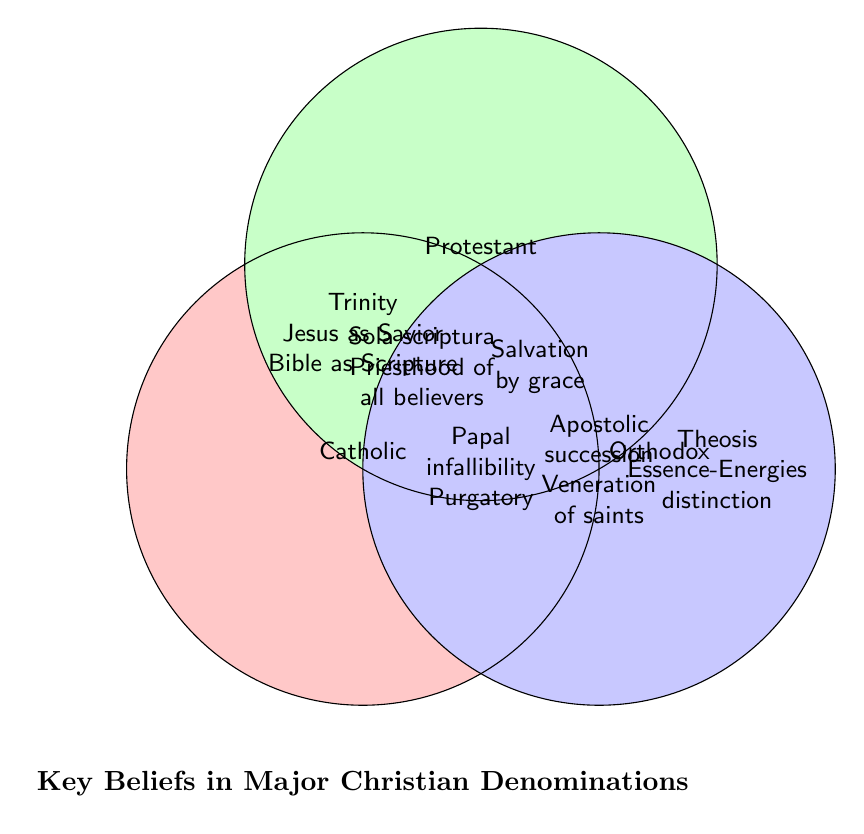What three beliefs are shared by all three denominations? The center of the Venn Diagram lists beliefs shared by all three denominations. These are "Trinity," "Jesus as Savior," and "Bible as Scripture."
Answer: Trinity, Jesus as Savior, Bible as Scripture Which belief is unique to Catholics? The section of the Venn Diagram that only overlaps with the Catholic circle lists beliefs unique to this denomination. These beliefs are "Papal infallibility" and "Purgatory."
Answer: Papal infallibility, Purgatory Which denominations believe in "Salvation by grace"? The section that overlaps between Catholic and Protestant denominations shows the belief "Salvation by grace."
Answer: Catholic, Protestant What's common between Catholic and Orthodox churches but not Protestant? The overlapping section between Catholic and Orthodox denominations, excluding the Protestant circle, lists "Apostolic succession" and "Veneration of saints."
Answer: Apostolic succession, Veneration of saints How many unique beliefs does the Orthodox denomination have on the diagram? The area exclusive to the Orthodox circle lists its unique beliefs. These beliefs are "Theosis" and "Essence-Energies distinction." Thus, there are two unique beliefs.
Answer: 2 beliefs Which belief is unique to the Protestant denomination? The section of the Venn Diagram that only overlaps with the Protestant circle lists beliefs unique to this denomination. These beliefs are "Sola scriptura" and "Priesthood of all believers."
Answer: Sola scriptura, Priesthood of all believers Are there more beliefs exclusive to Catholics or Protestants? The Catholic denomination has two exclusive beliefs ("Papal infallibility" and "Purgatory") and the Protestant denomination has two exclusive beliefs ("Sola scriptura" and "Priesthood of all believers"). Both have the same number of exclusive beliefs.
Answer: Same amount Which common belief do Catholic and Orthodox denominations share that Protestant does not? The overlapping section between Catholic and Orthodox denominations, excluding the Protestant circle, lists their common beliefs. These are "Apostolic succession" and "Veneration of saints."
Answer: Apostolic succession, Veneration of saints What belief differentiates the Orthodox denomination from the others? The exclusive beliefs listed in the Orthodox circle differentiate it from the others. These are "Theosis" and "Essence-Energies distinction."
Answer: Theosis, Essence-Energies distinction 